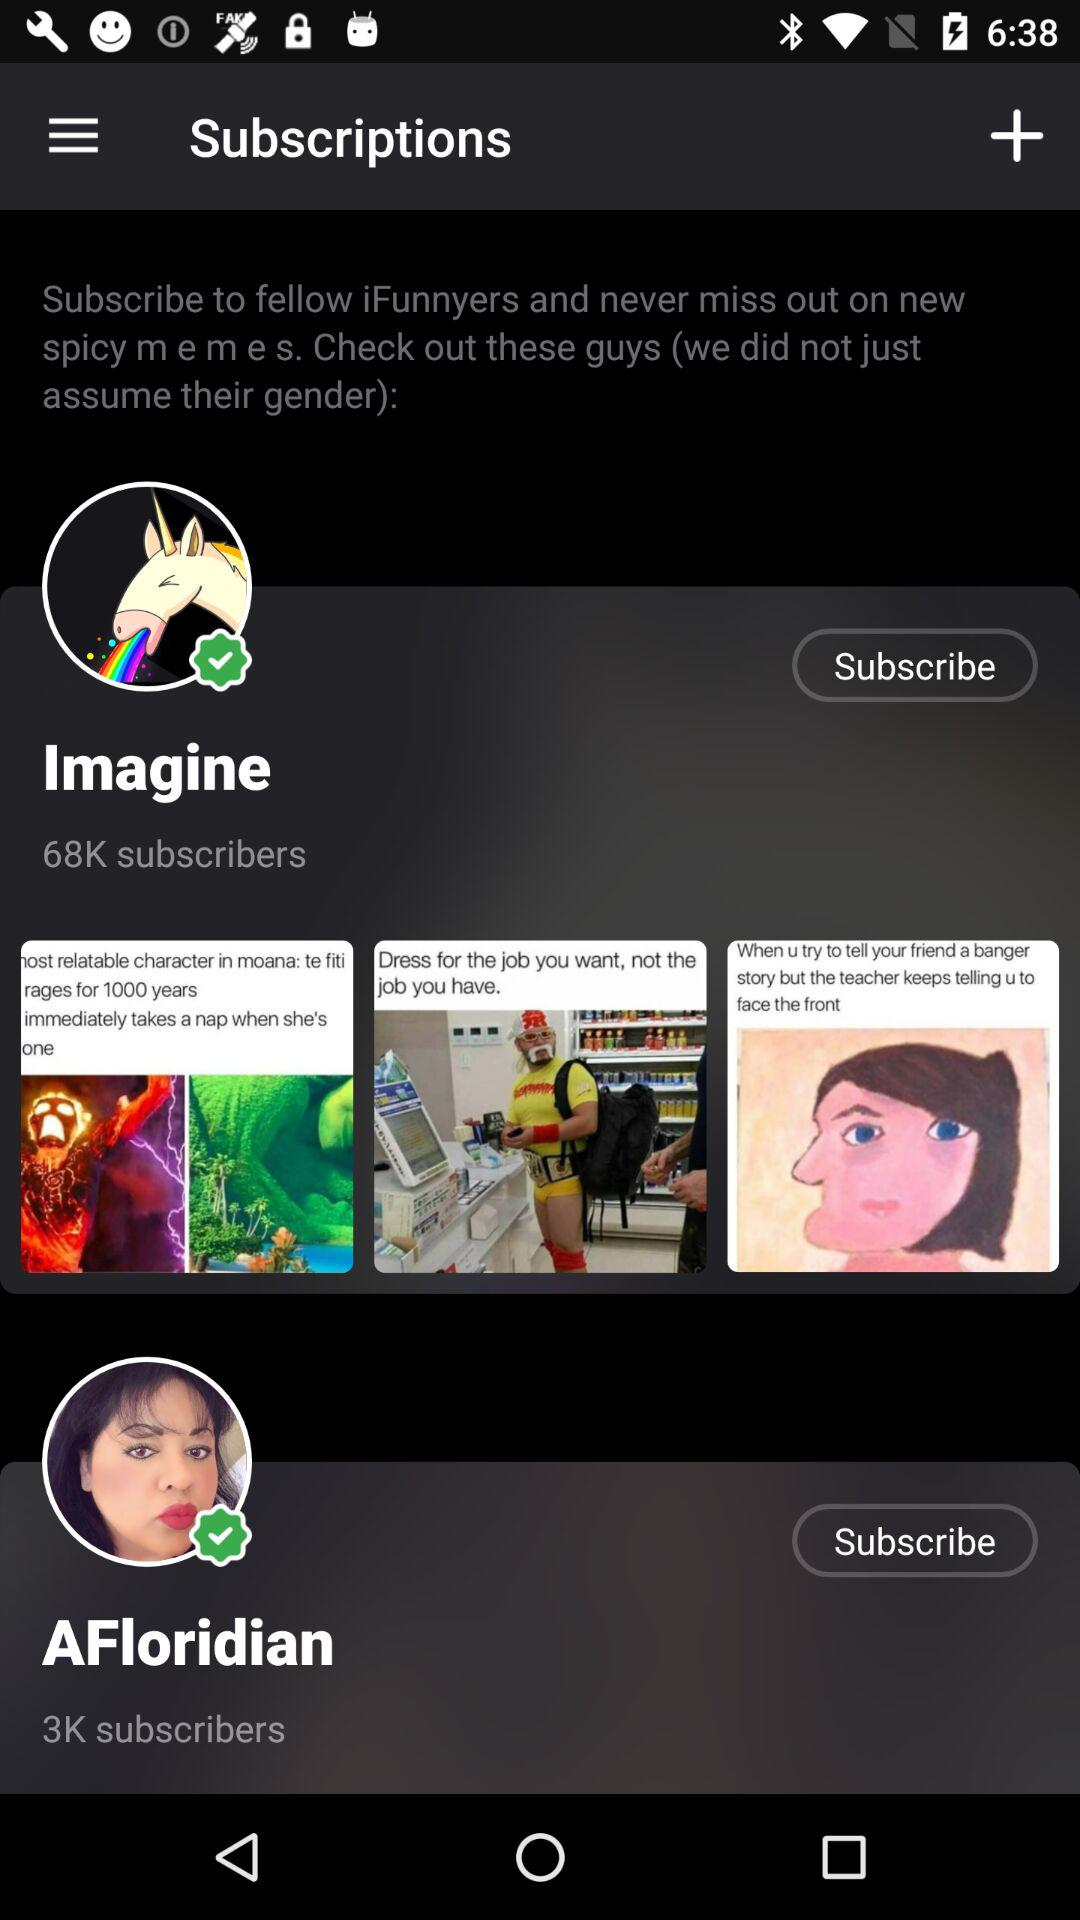How many subscribers does the user with the unicorn sticker have?
Answer the question using a single word or phrase. 68K 